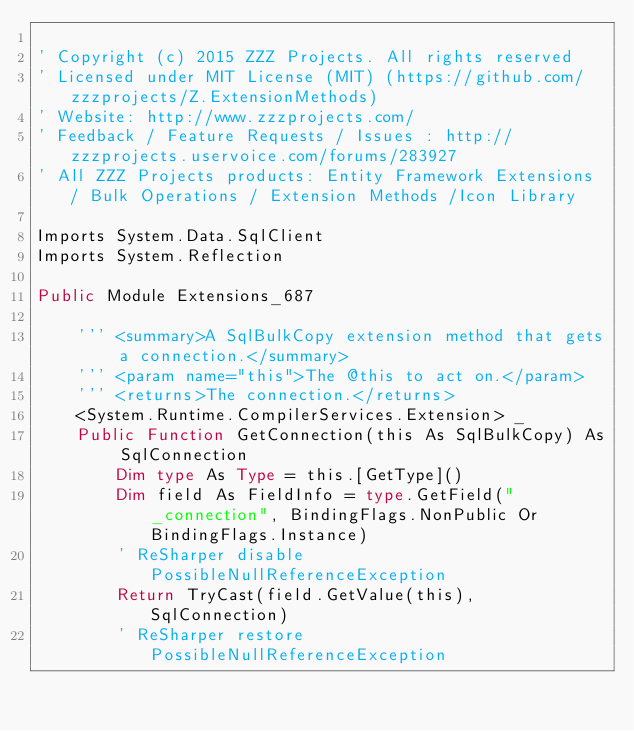<code> <loc_0><loc_0><loc_500><loc_500><_VisualBasic_>
' Copyright (c) 2015 ZZZ Projects. All rights reserved
' Licensed under MIT License (MIT) (https://github.com/zzzprojects/Z.ExtensionMethods)
' Website: http://www.zzzprojects.com/
' Feedback / Feature Requests / Issues : http://zzzprojects.uservoice.com/forums/283927
' All ZZZ Projects products: Entity Framework Extensions / Bulk Operations / Extension Methods /Icon Library

Imports System.Data.SqlClient
Imports System.Reflection

Public Module Extensions_687

	''' <summary>A SqlBulkCopy extension method that gets a connection.</summary>
	''' <param name="this">The @this to act on.</param>
	''' <returns>The connection.</returns>
	<System.Runtime.CompilerServices.Extension> _
	Public Function GetConnection(this As SqlBulkCopy) As SqlConnection
		Dim type As Type = this.[GetType]()
		Dim field As FieldInfo = type.GetField("_connection", BindingFlags.NonPublic Or BindingFlags.Instance)
		' ReSharper disable PossibleNullReferenceException
		Return TryCast(field.GetValue(this), SqlConnection)
		' ReSharper restore PossibleNullReferenceException</code> 